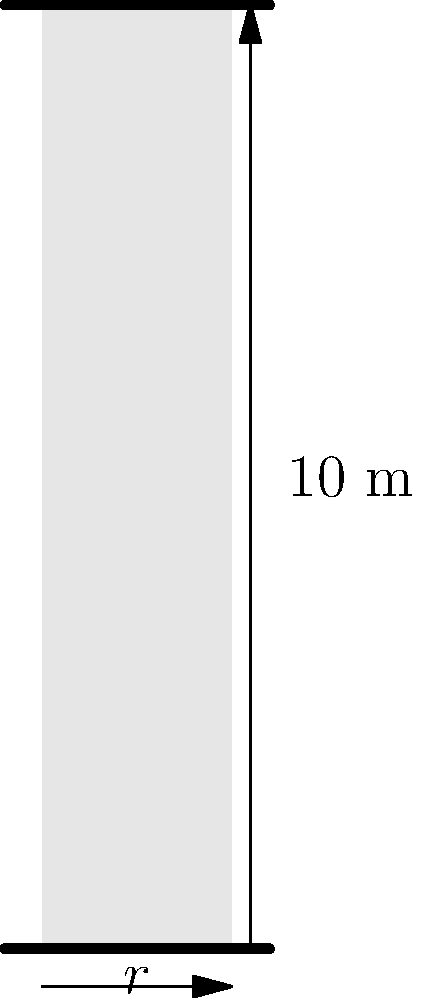An ancient Greek column discovered during an archaeological excavation is found to be perfectly cylindrical. The height of the column is measured to be 10 meters, and its volume is calculated to be $5\pi$ cubic meters. What is the radius of the column to the nearest centimeter? To solve this problem, we'll use the formula for the volume of a cylinder and work backwards to find the radius. Let's approach this step-by-step:

1) The formula for the volume of a cylinder is:
   $V = \pi r^2 h$
   Where $V$ is volume, $r$ is radius, and $h$ is height.

2) We know:
   - Volume ($V$) = $5\pi$ cubic meters
   - Height ($h$) = 10 meters

3) Let's substitute these values into the formula:
   $5\pi = \pi r^2 \cdot 10$

4) Simplify:
   $5\pi = 10\pi r^2$

5) Divide both sides by $10\pi$:
   $\frac{5\pi}{10\pi} = r^2$

6) Simplify:
   $0.5 = r^2$

7) Take the square root of both sides:
   $\sqrt{0.5} = r$

8) Calculate:
   $r \approx 0.7071$ meters

9) Convert to centimeters:
   $0.7071 \text{ meters} = 70.71 \text{ centimeters}$

10) Rounding to the nearest centimeter:
    $r = 71 \text{ cm}$
Answer: 71 cm 